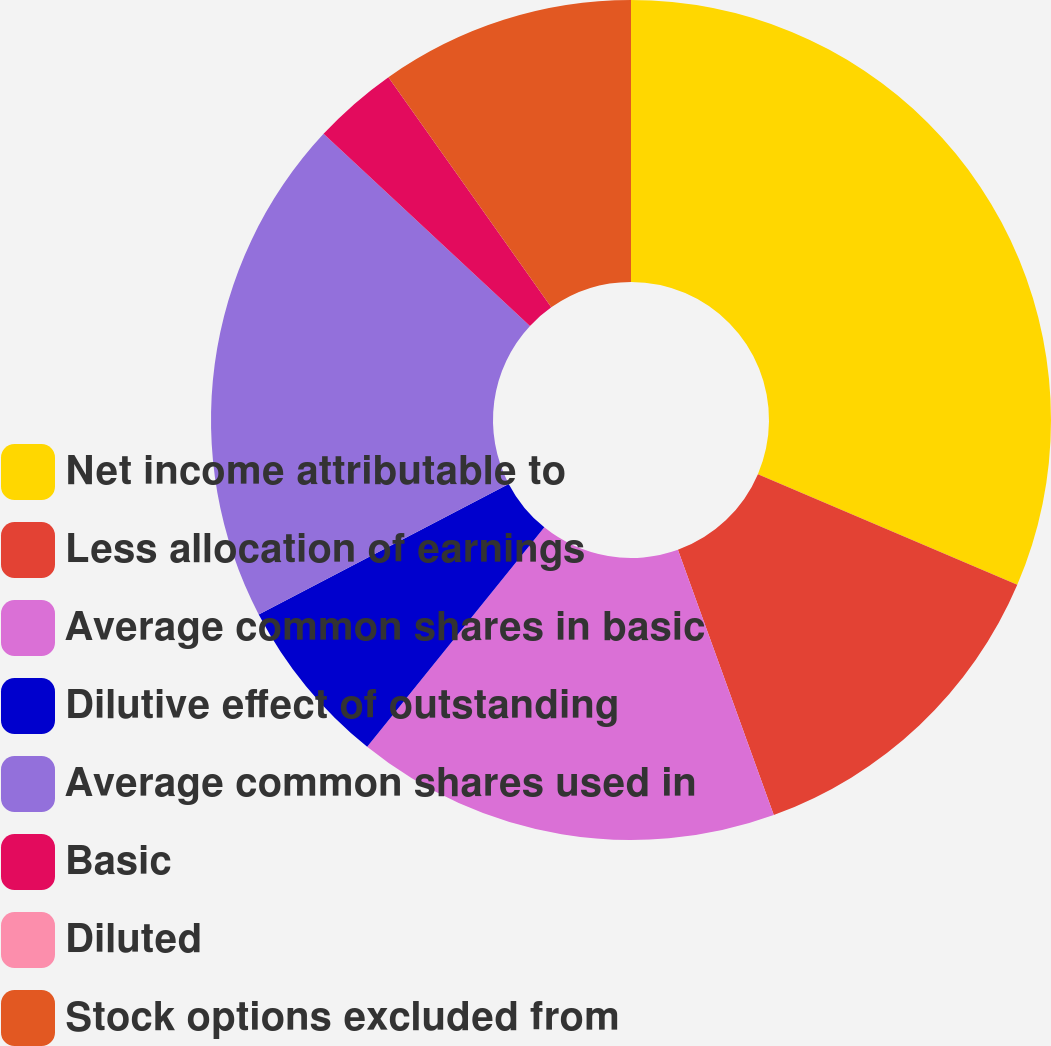Convert chart. <chart><loc_0><loc_0><loc_500><loc_500><pie_chart><fcel>Net income attributable to<fcel>Less allocation of earnings<fcel>Average common shares in basic<fcel>Dilutive effect of outstanding<fcel>Average common shares used in<fcel>Basic<fcel>Diluted<fcel>Stock options excluded from<nl><fcel>31.42%<fcel>13.06%<fcel>16.33%<fcel>6.53%<fcel>19.59%<fcel>3.27%<fcel>0.0%<fcel>9.8%<nl></chart> 